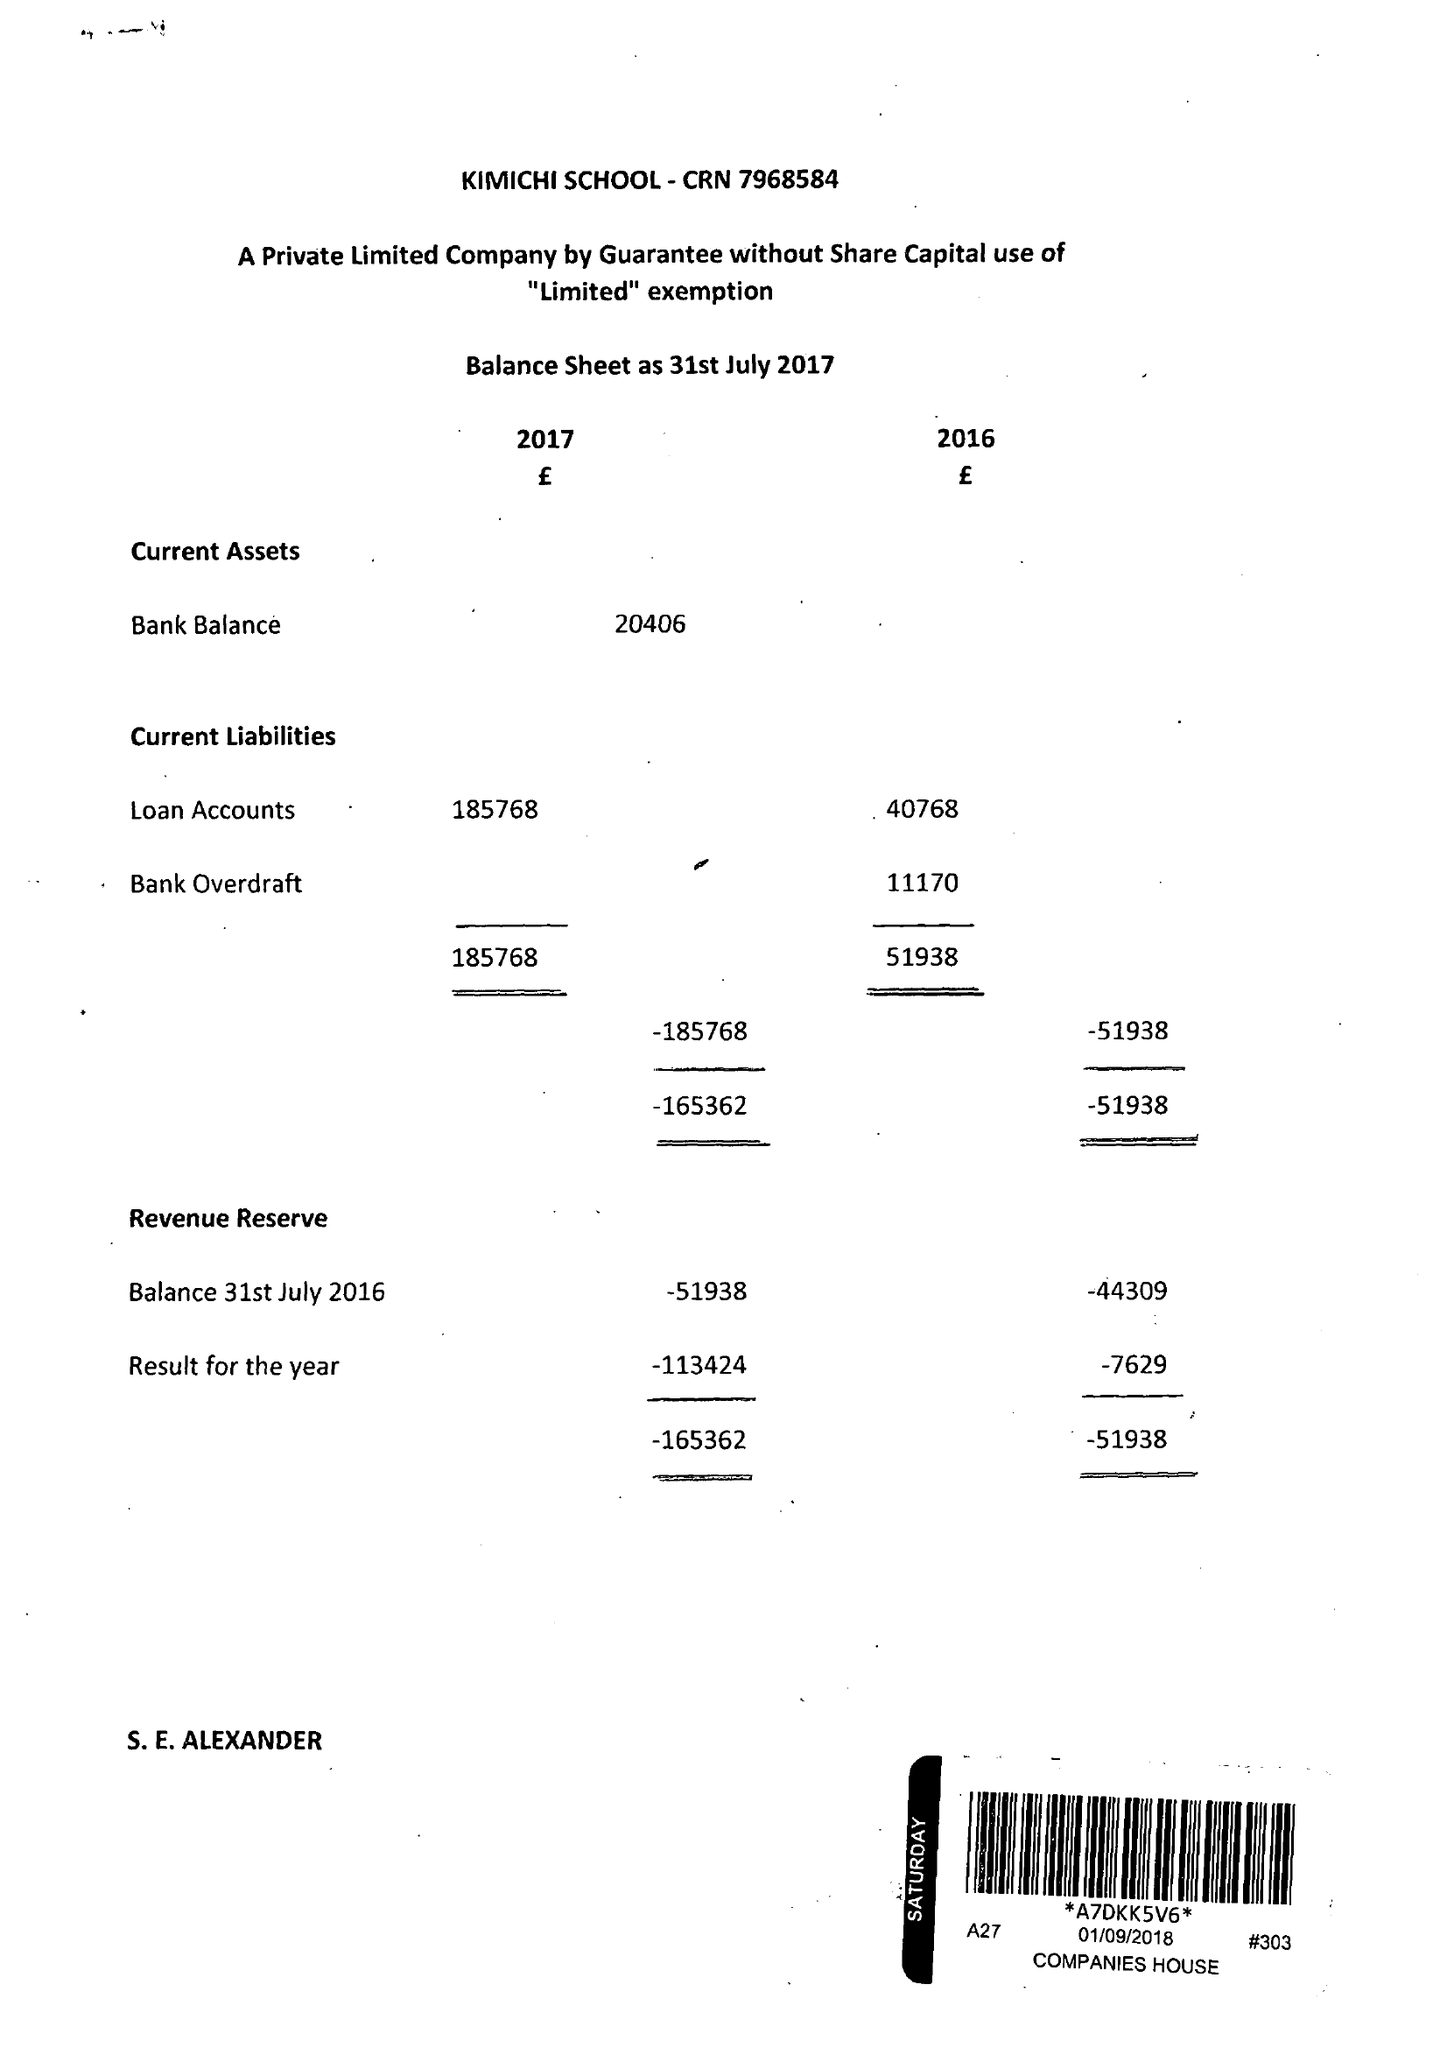What is the value for the income_annually_in_british_pounds?
Answer the question using a single word or phrase. 88111.00 